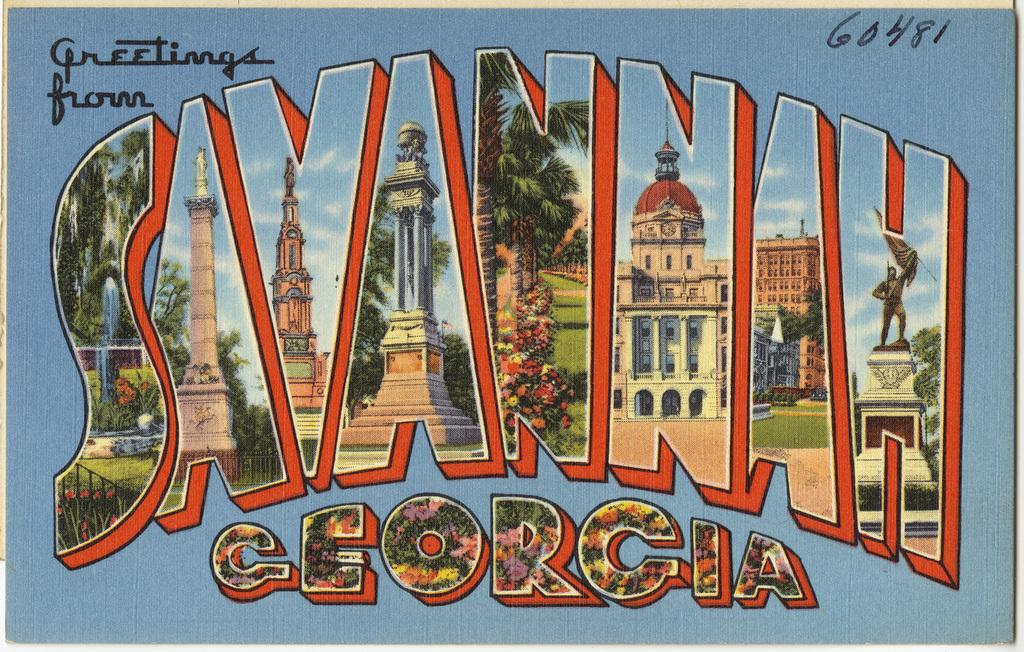<image>
Describe the image concisely. An orange and blue post card offers greetings from Savannah, Georgia. 